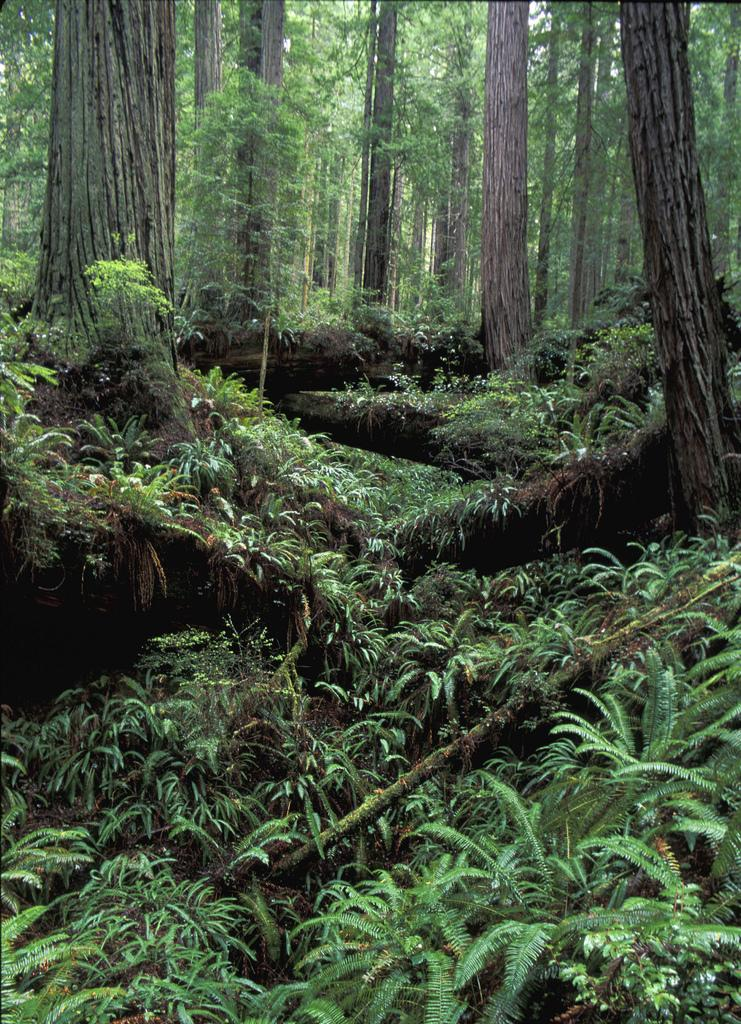What type of vegetation can be seen in the image? There are trees in the image. What color are the trees in the image? The trees are green in color. How many degrees are the trees tilted in the image? The trees are not tilted in the image, so it is not possible to determine the degree of tilt. 